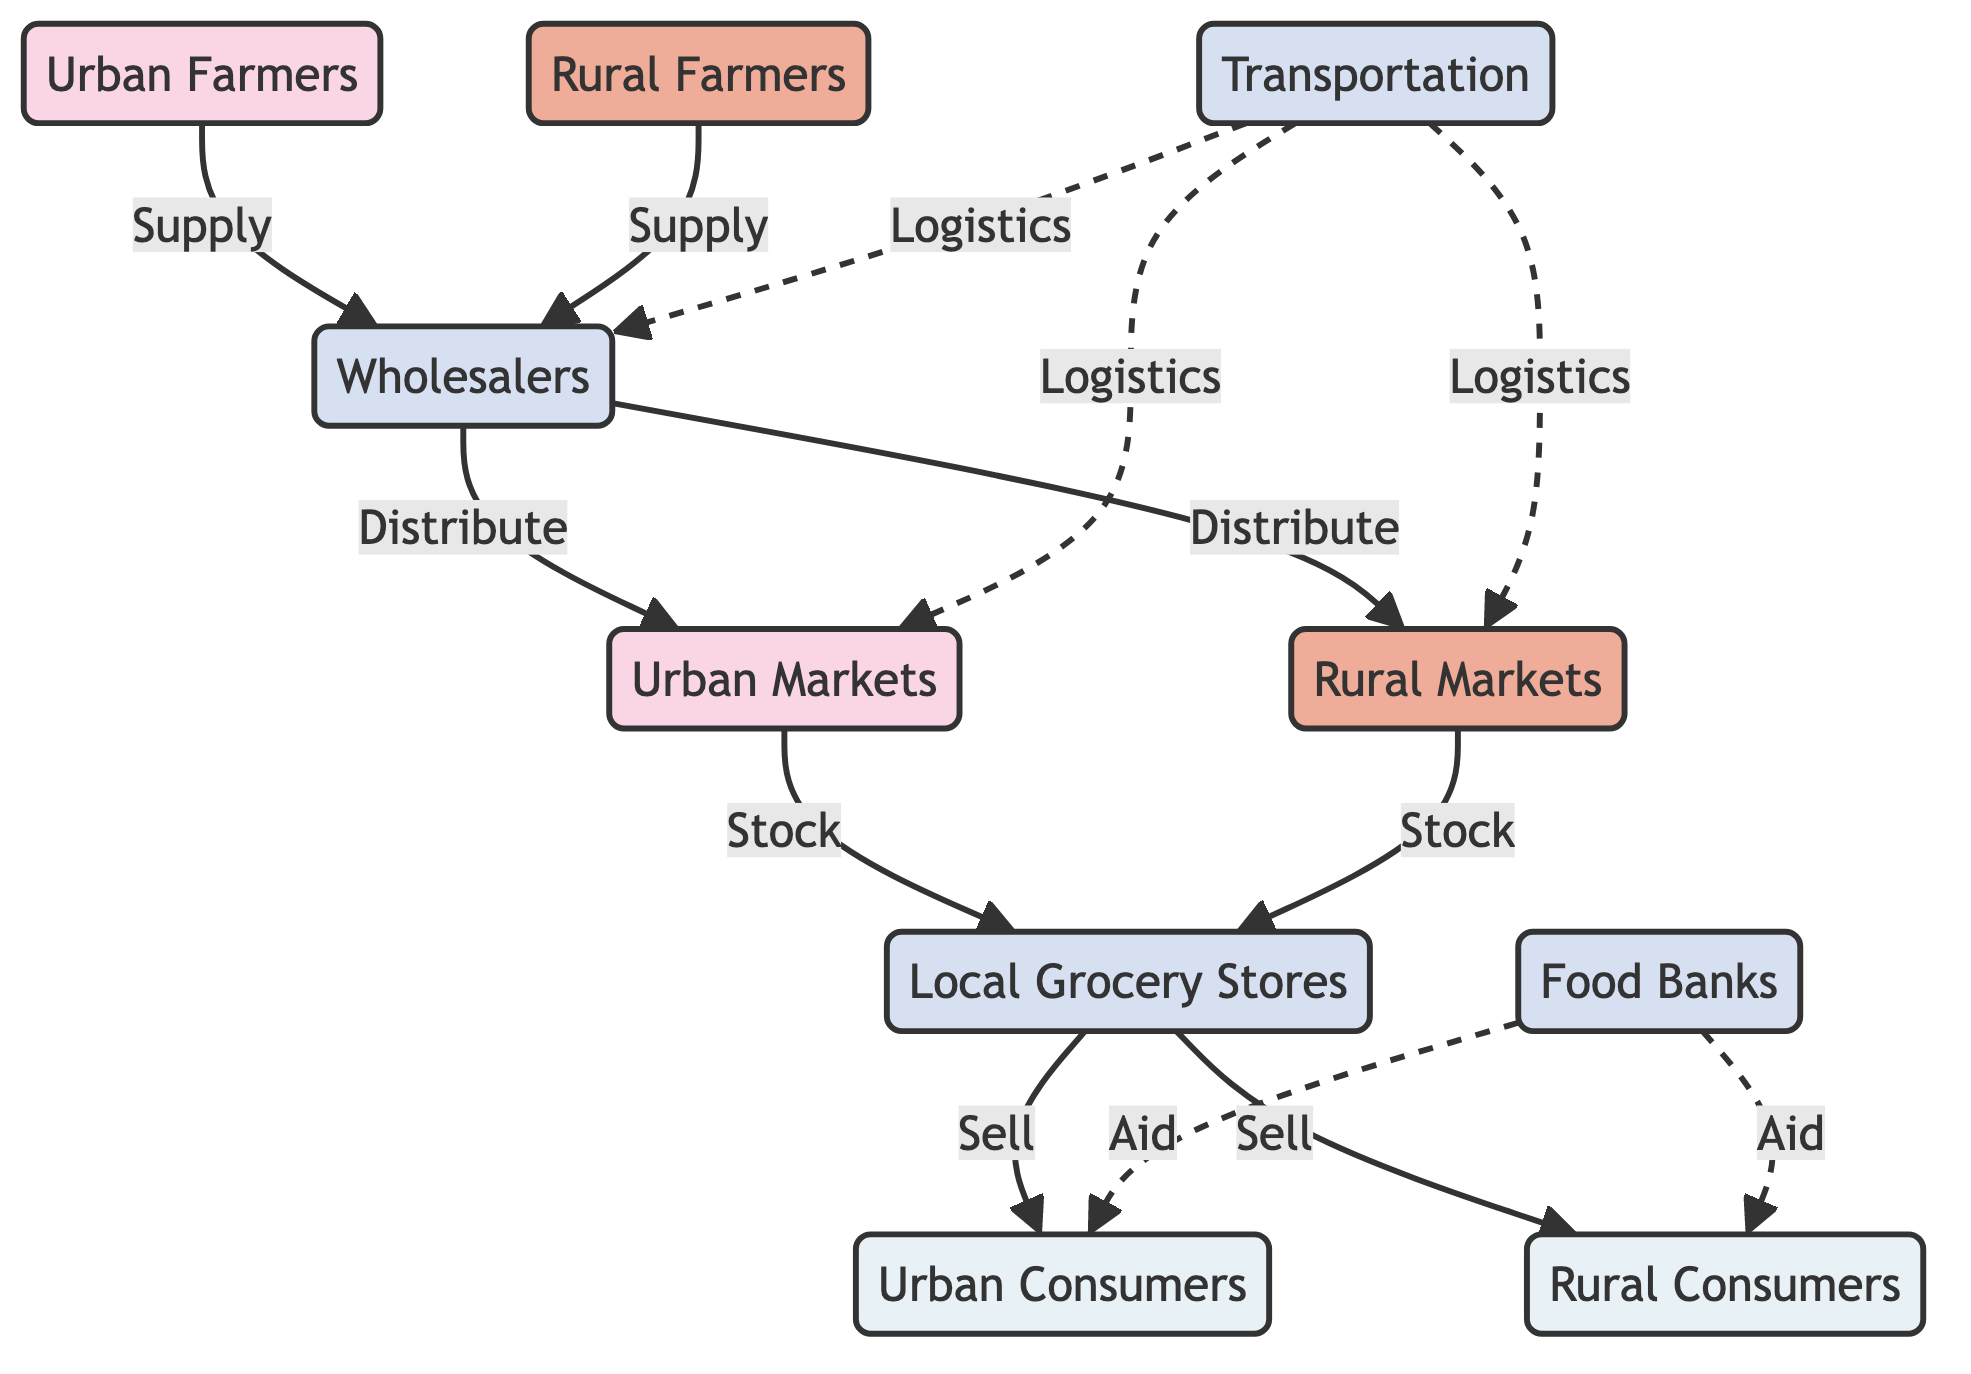What are the two types of farmers mentioned in the diagram? The diagram lists "Urban Farmers" and "Rural Farmers" as the two types of farmers.
Answer: Urban Farmers, Rural Farmers How do rural farmers supply the food chain? Rural Farmers supply the food chain by connecting directly to the wholesalers, as indicated by the arrow labeled "Supply."
Answer: Supply Which markets receive food from wholesalers? The wholesaler distributes food to both "Urban Markets" and "Rural Markets," as depicted in the diagram.
Answer: Urban Markets, Rural Markets What role do food banks play in the diagram? Food Banks provide aid to both urban and rural consumers, illustrated by the dashed lines pointing to the consumer nodes.
Answer: Aid Which node connects local grocery stores to urban consumers? Local grocery stores sell directly to "Consumers Urban," showing their connection in the diagram.
Answer: Consumers Urban What common service is provided by transportation in the diagram? Transportation plays a logistics role, connecting wholesalers, urban markets, and rural markets, as indicated by the dashed arrows.
Answer: Logistics How many main consumer nodes are there in the diagram? The diagram features two main consumer nodes: "Consumers Urban" and "Consumers Rural."
Answer: 2 What is the relationship between urban markets and local grocery stores? Urban Markets stock local grocery stores, meaning urban markets supply products to these stores for sale to consumers.
Answer: Stock How are wholesalers depicted with respect to farmers? Wholesalers are connected to both types of farmers (urban and rural) through supply lines, indicating they are intermediaries.
Answer: Intermediaries 